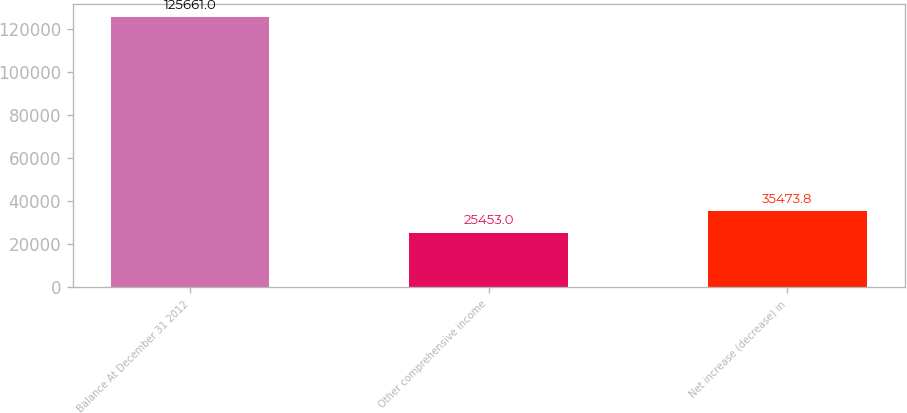Convert chart to OTSL. <chart><loc_0><loc_0><loc_500><loc_500><bar_chart><fcel>Balance At December 31 2012<fcel>Other comprehensive income<fcel>Net increase (decrease) in<nl><fcel>125661<fcel>25453<fcel>35473.8<nl></chart> 